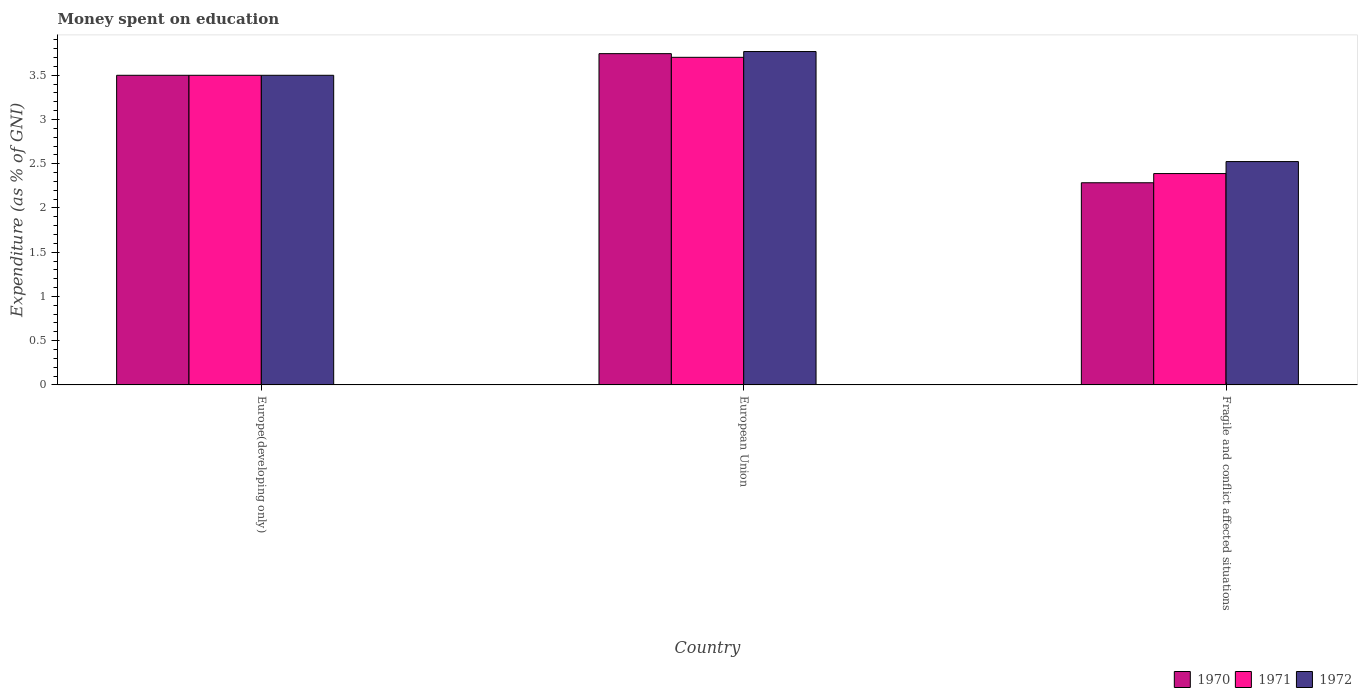How many different coloured bars are there?
Give a very brief answer. 3. How many groups of bars are there?
Ensure brevity in your answer.  3. Are the number of bars on each tick of the X-axis equal?
Ensure brevity in your answer.  Yes. How many bars are there on the 1st tick from the right?
Offer a very short reply. 3. What is the label of the 1st group of bars from the left?
Give a very brief answer. Europe(developing only). Across all countries, what is the maximum amount of money spent on education in 1971?
Give a very brief answer. 3.7. Across all countries, what is the minimum amount of money spent on education in 1972?
Give a very brief answer. 2.52. In which country was the amount of money spent on education in 1972 minimum?
Your response must be concise. Fragile and conflict affected situations. What is the total amount of money spent on education in 1970 in the graph?
Your response must be concise. 9.53. What is the difference between the amount of money spent on education in 1971 in European Union and that in Fragile and conflict affected situations?
Make the answer very short. 1.31. What is the difference between the amount of money spent on education in 1971 in Fragile and conflict affected situations and the amount of money spent on education in 1972 in European Union?
Offer a very short reply. -1.38. What is the average amount of money spent on education in 1972 per country?
Provide a short and direct response. 3.26. What is the difference between the amount of money spent on education of/in 1972 and amount of money spent on education of/in 1971 in European Union?
Your answer should be compact. 0.07. In how many countries, is the amount of money spent on education in 1971 greater than 1.7 %?
Your answer should be very brief. 3. What is the ratio of the amount of money spent on education in 1971 in Europe(developing only) to that in Fragile and conflict affected situations?
Your answer should be very brief. 1.47. What is the difference between the highest and the second highest amount of money spent on education in 1970?
Your answer should be very brief. 1.21. What is the difference between the highest and the lowest amount of money spent on education in 1970?
Keep it short and to the point. 1.46. What does the 2nd bar from the right in European Union represents?
Provide a short and direct response. 1971. Is it the case that in every country, the sum of the amount of money spent on education in 1972 and amount of money spent on education in 1970 is greater than the amount of money spent on education in 1971?
Provide a short and direct response. Yes. How many countries are there in the graph?
Give a very brief answer. 3. What is the title of the graph?
Provide a short and direct response. Money spent on education. What is the label or title of the Y-axis?
Make the answer very short. Expenditure (as % of GNI). What is the Expenditure (as % of GNI) in 1972 in Europe(developing only)?
Your answer should be compact. 3.5. What is the Expenditure (as % of GNI) of 1970 in European Union?
Provide a short and direct response. 3.74. What is the Expenditure (as % of GNI) of 1971 in European Union?
Make the answer very short. 3.7. What is the Expenditure (as % of GNI) of 1972 in European Union?
Your answer should be very brief. 3.77. What is the Expenditure (as % of GNI) in 1970 in Fragile and conflict affected situations?
Offer a terse response. 2.29. What is the Expenditure (as % of GNI) in 1971 in Fragile and conflict affected situations?
Provide a short and direct response. 2.39. What is the Expenditure (as % of GNI) of 1972 in Fragile and conflict affected situations?
Ensure brevity in your answer.  2.52. Across all countries, what is the maximum Expenditure (as % of GNI) of 1970?
Offer a very short reply. 3.74. Across all countries, what is the maximum Expenditure (as % of GNI) of 1971?
Provide a succinct answer. 3.7. Across all countries, what is the maximum Expenditure (as % of GNI) in 1972?
Keep it short and to the point. 3.77. Across all countries, what is the minimum Expenditure (as % of GNI) of 1970?
Provide a succinct answer. 2.29. Across all countries, what is the minimum Expenditure (as % of GNI) in 1971?
Ensure brevity in your answer.  2.39. Across all countries, what is the minimum Expenditure (as % of GNI) of 1972?
Your answer should be compact. 2.52. What is the total Expenditure (as % of GNI) in 1970 in the graph?
Provide a short and direct response. 9.53. What is the total Expenditure (as % of GNI) in 1971 in the graph?
Give a very brief answer. 9.59. What is the total Expenditure (as % of GNI) of 1972 in the graph?
Your response must be concise. 9.79. What is the difference between the Expenditure (as % of GNI) in 1970 in Europe(developing only) and that in European Union?
Offer a terse response. -0.24. What is the difference between the Expenditure (as % of GNI) of 1971 in Europe(developing only) and that in European Union?
Provide a short and direct response. -0.2. What is the difference between the Expenditure (as % of GNI) of 1972 in Europe(developing only) and that in European Union?
Offer a very short reply. -0.27. What is the difference between the Expenditure (as % of GNI) of 1970 in Europe(developing only) and that in Fragile and conflict affected situations?
Make the answer very short. 1.21. What is the difference between the Expenditure (as % of GNI) of 1971 in Europe(developing only) and that in Fragile and conflict affected situations?
Make the answer very short. 1.11. What is the difference between the Expenditure (as % of GNI) of 1972 in Europe(developing only) and that in Fragile and conflict affected situations?
Offer a terse response. 0.98. What is the difference between the Expenditure (as % of GNI) of 1970 in European Union and that in Fragile and conflict affected situations?
Your answer should be very brief. 1.46. What is the difference between the Expenditure (as % of GNI) of 1971 in European Union and that in Fragile and conflict affected situations?
Offer a terse response. 1.31. What is the difference between the Expenditure (as % of GNI) of 1972 in European Union and that in Fragile and conflict affected situations?
Your response must be concise. 1.24. What is the difference between the Expenditure (as % of GNI) of 1970 in Europe(developing only) and the Expenditure (as % of GNI) of 1971 in European Union?
Your response must be concise. -0.2. What is the difference between the Expenditure (as % of GNI) in 1970 in Europe(developing only) and the Expenditure (as % of GNI) in 1972 in European Union?
Provide a succinct answer. -0.27. What is the difference between the Expenditure (as % of GNI) of 1971 in Europe(developing only) and the Expenditure (as % of GNI) of 1972 in European Union?
Your answer should be compact. -0.27. What is the difference between the Expenditure (as % of GNI) in 1970 in Europe(developing only) and the Expenditure (as % of GNI) in 1971 in Fragile and conflict affected situations?
Ensure brevity in your answer.  1.11. What is the difference between the Expenditure (as % of GNI) in 1970 in Europe(developing only) and the Expenditure (as % of GNI) in 1972 in Fragile and conflict affected situations?
Offer a very short reply. 0.98. What is the difference between the Expenditure (as % of GNI) of 1971 in Europe(developing only) and the Expenditure (as % of GNI) of 1972 in Fragile and conflict affected situations?
Your answer should be very brief. 0.98. What is the difference between the Expenditure (as % of GNI) in 1970 in European Union and the Expenditure (as % of GNI) in 1971 in Fragile and conflict affected situations?
Give a very brief answer. 1.36. What is the difference between the Expenditure (as % of GNI) of 1970 in European Union and the Expenditure (as % of GNI) of 1972 in Fragile and conflict affected situations?
Offer a terse response. 1.22. What is the difference between the Expenditure (as % of GNI) of 1971 in European Union and the Expenditure (as % of GNI) of 1972 in Fragile and conflict affected situations?
Keep it short and to the point. 1.18. What is the average Expenditure (as % of GNI) in 1970 per country?
Ensure brevity in your answer.  3.18. What is the average Expenditure (as % of GNI) of 1971 per country?
Offer a very short reply. 3.2. What is the average Expenditure (as % of GNI) of 1972 per country?
Offer a very short reply. 3.26. What is the difference between the Expenditure (as % of GNI) of 1970 and Expenditure (as % of GNI) of 1971 in Europe(developing only)?
Make the answer very short. 0. What is the difference between the Expenditure (as % of GNI) of 1970 and Expenditure (as % of GNI) of 1972 in Europe(developing only)?
Your response must be concise. 0. What is the difference between the Expenditure (as % of GNI) of 1970 and Expenditure (as % of GNI) of 1971 in European Union?
Offer a terse response. 0.04. What is the difference between the Expenditure (as % of GNI) in 1970 and Expenditure (as % of GNI) in 1972 in European Union?
Ensure brevity in your answer.  -0.02. What is the difference between the Expenditure (as % of GNI) of 1971 and Expenditure (as % of GNI) of 1972 in European Union?
Offer a terse response. -0.07. What is the difference between the Expenditure (as % of GNI) of 1970 and Expenditure (as % of GNI) of 1971 in Fragile and conflict affected situations?
Ensure brevity in your answer.  -0.1. What is the difference between the Expenditure (as % of GNI) in 1970 and Expenditure (as % of GNI) in 1972 in Fragile and conflict affected situations?
Ensure brevity in your answer.  -0.24. What is the difference between the Expenditure (as % of GNI) in 1971 and Expenditure (as % of GNI) in 1972 in Fragile and conflict affected situations?
Offer a terse response. -0.14. What is the ratio of the Expenditure (as % of GNI) in 1970 in Europe(developing only) to that in European Union?
Make the answer very short. 0.93. What is the ratio of the Expenditure (as % of GNI) in 1971 in Europe(developing only) to that in European Union?
Keep it short and to the point. 0.95. What is the ratio of the Expenditure (as % of GNI) of 1972 in Europe(developing only) to that in European Union?
Offer a terse response. 0.93. What is the ratio of the Expenditure (as % of GNI) in 1970 in Europe(developing only) to that in Fragile and conflict affected situations?
Your answer should be very brief. 1.53. What is the ratio of the Expenditure (as % of GNI) of 1971 in Europe(developing only) to that in Fragile and conflict affected situations?
Give a very brief answer. 1.47. What is the ratio of the Expenditure (as % of GNI) in 1972 in Europe(developing only) to that in Fragile and conflict affected situations?
Ensure brevity in your answer.  1.39. What is the ratio of the Expenditure (as % of GNI) of 1970 in European Union to that in Fragile and conflict affected situations?
Your answer should be compact. 1.64. What is the ratio of the Expenditure (as % of GNI) of 1971 in European Union to that in Fragile and conflict affected situations?
Provide a succinct answer. 1.55. What is the ratio of the Expenditure (as % of GNI) of 1972 in European Union to that in Fragile and conflict affected situations?
Your answer should be very brief. 1.49. What is the difference between the highest and the second highest Expenditure (as % of GNI) of 1970?
Offer a terse response. 0.24. What is the difference between the highest and the second highest Expenditure (as % of GNI) in 1971?
Offer a very short reply. 0.2. What is the difference between the highest and the second highest Expenditure (as % of GNI) of 1972?
Provide a short and direct response. 0.27. What is the difference between the highest and the lowest Expenditure (as % of GNI) in 1970?
Provide a succinct answer. 1.46. What is the difference between the highest and the lowest Expenditure (as % of GNI) of 1971?
Provide a short and direct response. 1.31. What is the difference between the highest and the lowest Expenditure (as % of GNI) of 1972?
Your answer should be very brief. 1.24. 